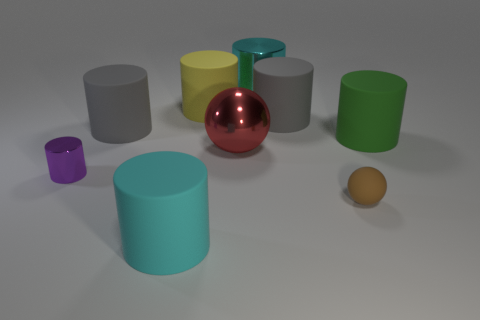Subtract all blue blocks. How many cyan cylinders are left? 2 Subtract all yellow cylinders. How many cylinders are left? 6 Subtract all small cylinders. How many cylinders are left? 6 Subtract 4 cylinders. How many cylinders are left? 3 Add 1 small brown metallic balls. How many objects exist? 10 Subtract all gray cylinders. Subtract all cyan spheres. How many cylinders are left? 5 Subtract all spheres. How many objects are left? 7 Add 7 gray rubber cylinders. How many gray rubber cylinders exist? 9 Subtract 1 yellow cylinders. How many objects are left? 8 Subtract all large yellow matte balls. Subtract all big cyan metallic cylinders. How many objects are left? 8 